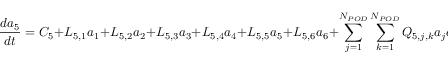<formula> <loc_0><loc_0><loc_500><loc_500>\frac { d a _ { 5 } } { d t } = C _ { 5 } + L _ { 5 , 1 } a _ { 1 } + L _ { 5 , 2 } a _ { 2 } + L _ { 5 , 3 } a _ { 3 } + L _ { 5 , 4 } a _ { 4 } + L _ { 5 , 5 } a _ { 5 } + L _ { 5 , 6 } a _ { 6 } + \sum _ { j = 1 } ^ { N _ { P O D } } \sum _ { k = 1 } ^ { N _ { P O D } } Q _ { 5 , j , k } a _ { j } a _ { k }</formula> 